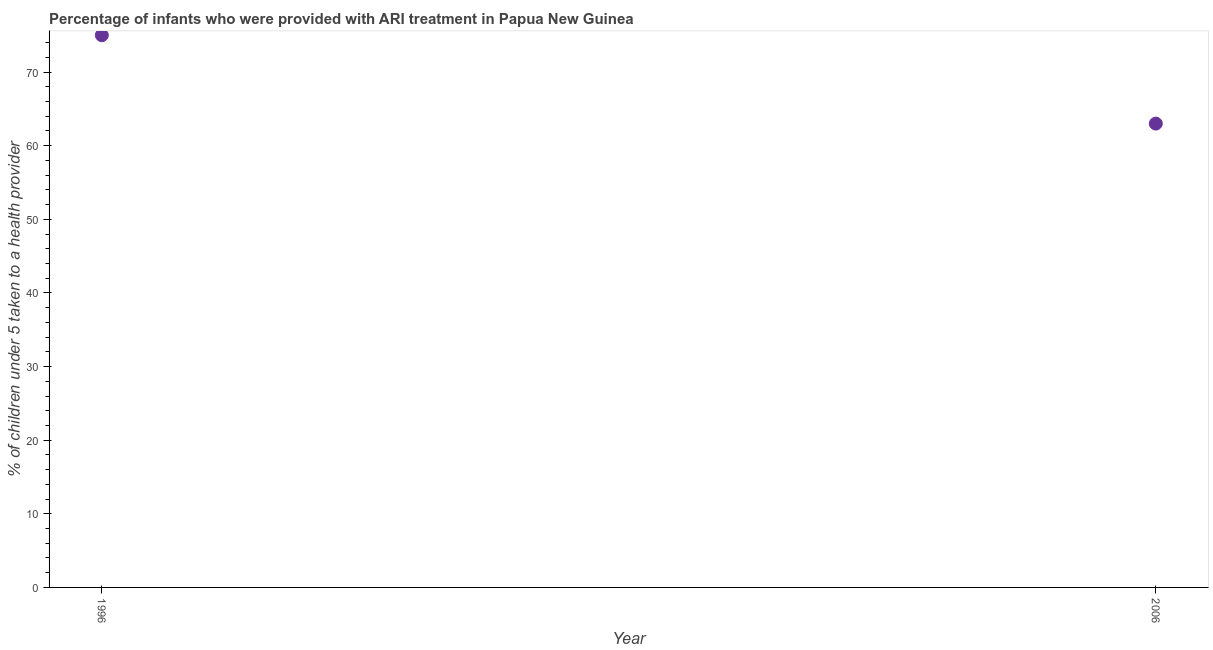What is the percentage of children who were provided with ari treatment in 2006?
Your response must be concise. 63. Across all years, what is the maximum percentage of children who were provided with ari treatment?
Give a very brief answer. 75. Across all years, what is the minimum percentage of children who were provided with ari treatment?
Give a very brief answer. 63. In which year was the percentage of children who were provided with ari treatment maximum?
Provide a short and direct response. 1996. What is the sum of the percentage of children who were provided with ari treatment?
Your answer should be very brief. 138. What is the difference between the percentage of children who were provided with ari treatment in 1996 and 2006?
Make the answer very short. 12. What is the median percentage of children who were provided with ari treatment?
Keep it short and to the point. 69. Do a majority of the years between 1996 and 2006 (inclusive) have percentage of children who were provided with ari treatment greater than 54 %?
Ensure brevity in your answer.  Yes. What is the ratio of the percentage of children who were provided with ari treatment in 1996 to that in 2006?
Provide a succinct answer. 1.19. Does the percentage of children who were provided with ari treatment monotonically increase over the years?
Provide a succinct answer. No. What is the difference between two consecutive major ticks on the Y-axis?
Provide a succinct answer. 10. Does the graph contain any zero values?
Your answer should be compact. No. Does the graph contain grids?
Give a very brief answer. No. What is the title of the graph?
Offer a very short reply. Percentage of infants who were provided with ARI treatment in Papua New Guinea. What is the label or title of the Y-axis?
Your answer should be compact. % of children under 5 taken to a health provider. What is the % of children under 5 taken to a health provider in 1996?
Offer a terse response. 75. What is the ratio of the % of children under 5 taken to a health provider in 1996 to that in 2006?
Your answer should be compact. 1.19. 